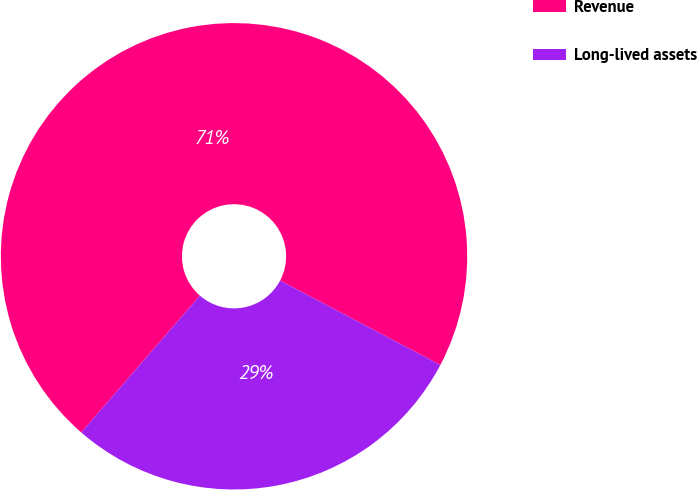Convert chart to OTSL. <chart><loc_0><loc_0><loc_500><loc_500><pie_chart><fcel>Revenue<fcel>Long-lived assets<nl><fcel>71.35%<fcel>28.65%<nl></chart> 